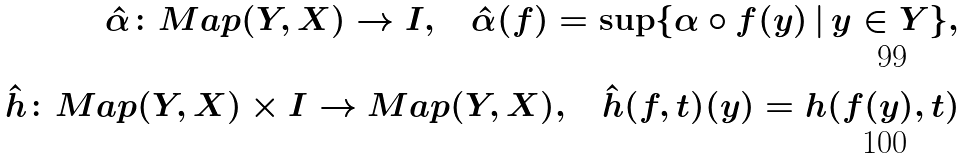<formula> <loc_0><loc_0><loc_500><loc_500>\hat { \alpha } \colon M a p ( Y , X ) \to I , \quad \hat { \alpha } ( f ) = \sup \{ \alpha \circ f ( y ) \, | \, y \in Y \} , \\ \hat { h } \colon M a p ( Y , X ) \times I \to M a p ( Y , X ) , \quad \hat { h } ( f , t ) ( y ) = h ( f ( y ) , t )</formula> 